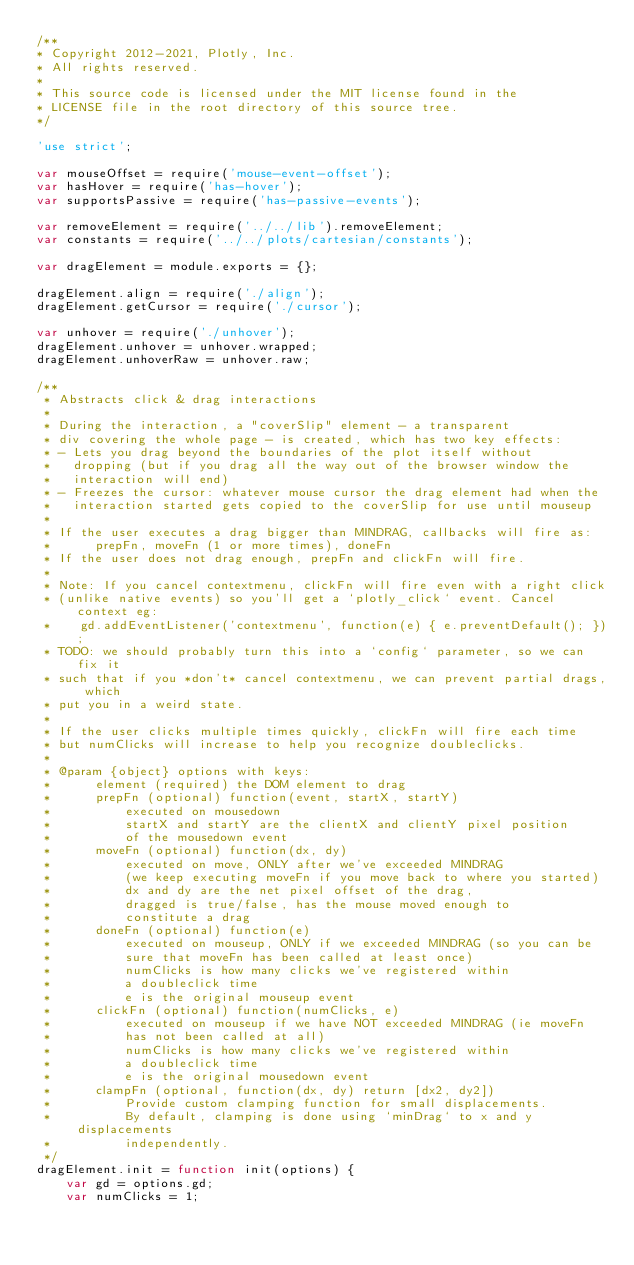Convert code to text. <code><loc_0><loc_0><loc_500><loc_500><_JavaScript_>/**
* Copyright 2012-2021, Plotly, Inc.
* All rights reserved.
*
* This source code is licensed under the MIT license found in the
* LICENSE file in the root directory of this source tree.
*/

'use strict';

var mouseOffset = require('mouse-event-offset');
var hasHover = require('has-hover');
var supportsPassive = require('has-passive-events');

var removeElement = require('../../lib').removeElement;
var constants = require('../../plots/cartesian/constants');

var dragElement = module.exports = {};

dragElement.align = require('./align');
dragElement.getCursor = require('./cursor');

var unhover = require('./unhover');
dragElement.unhover = unhover.wrapped;
dragElement.unhoverRaw = unhover.raw;

/**
 * Abstracts click & drag interactions
 *
 * During the interaction, a "coverSlip" element - a transparent
 * div covering the whole page - is created, which has two key effects:
 * - Lets you drag beyond the boundaries of the plot itself without
 *   dropping (but if you drag all the way out of the browser window the
 *   interaction will end)
 * - Freezes the cursor: whatever mouse cursor the drag element had when the
 *   interaction started gets copied to the coverSlip for use until mouseup
 *
 * If the user executes a drag bigger than MINDRAG, callbacks will fire as:
 *      prepFn, moveFn (1 or more times), doneFn
 * If the user does not drag enough, prepFn and clickFn will fire.
 *
 * Note: If you cancel contextmenu, clickFn will fire even with a right click
 * (unlike native events) so you'll get a `plotly_click` event. Cancel context eg:
 *    gd.addEventListener('contextmenu', function(e) { e.preventDefault(); });
 * TODO: we should probably turn this into a `config` parameter, so we can fix it
 * such that if you *don't* cancel contextmenu, we can prevent partial drags, which
 * put you in a weird state.
 *
 * If the user clicks multiple times quickly, clickFn will fire each time
 * but numClicks will increase to help you recognize doubleclicks.
 *
 * @param {object} options with keys:
 *      element (required) the DOM element to drag
 *      prepFn (optional) function(event, startX, startY)
 *          executed on mousedown
 *          startX and startY are the clientX and clientY pixel position
 *          of the mousedown event
 *      moveFn (optional) function(dx, dy)
 *          executed on move, ONLY after we've exceeded MINDRAG
 *          (we keep executing moveFn if you move back to where you started)
 *          dx and dy are the net pixel offset of the drag,
 *          dragged is true/false, has the mouse moved enough to
 *          constitute a drag
 *      doneFn (optional) function(e)
 *          executed on mouseup, ONLY if we exceeded MINDRAG (so you can be
 *          sure that moveFn has been called at least once)
 *          numClicks is how many clicks we've registered within
 *          a doubleclick time
 *          e is the original mouseup event
 *      clickFn (optional) function(numClicks, e)
 *          executed on mouseup if we have NOT exceeded MINDRAG (ie moveFn
 *          has not been called at all)
 *          numClicks is how many clicks we've registered within
 *          a doubleclick time
 *          e is the original mousedown event
 *      clampFn (optional, function(dx, dy) return [dx2, dy2])
 *          Provide custom clamping function for small displacements.
 *          By default, clamping is done using `minDrag` to x and y displacements
 *          independently.
 */
dragElement.init = function init(options) {
    var gd = options.gd;
    var numClicks = 1;</code> 